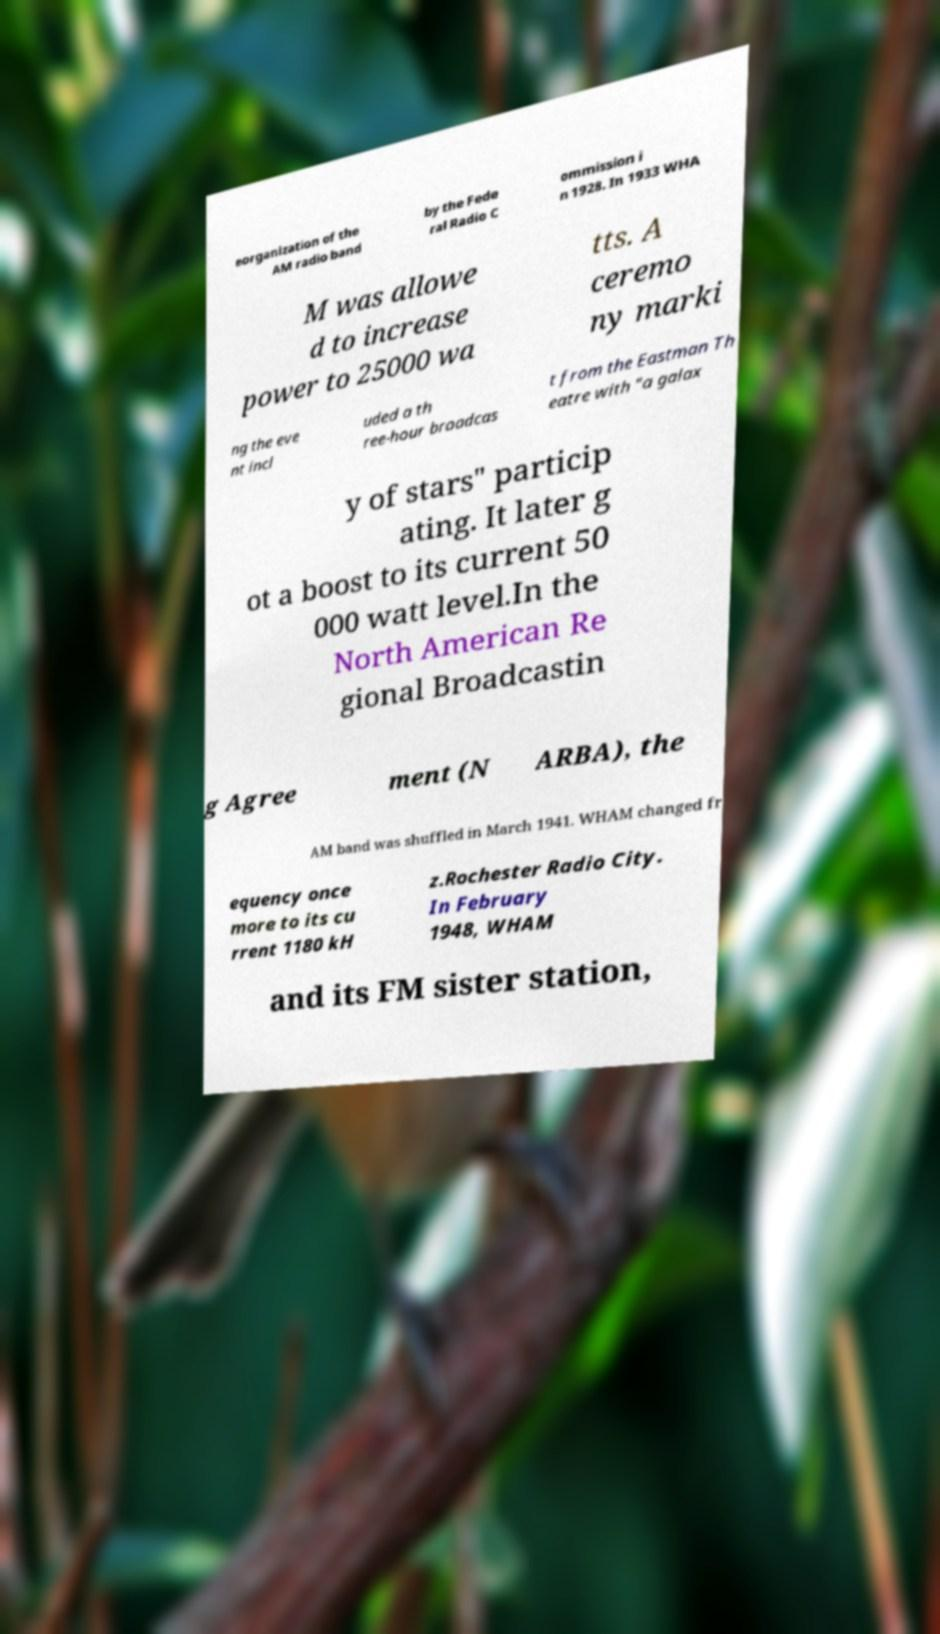There's text embedded in this image that I need extracted. Can you transcribe it verbatim? eorganization of the AM radio band by the Fede ral Radio C ommission i n 1928. In 1933 WHA M was allowe d to increase power to 25000 wa tts. A ceremo ny marki ng the eve nt incl uded a th ree-hour broadcas t from the Eastman Th eatre with "a galax y of stars" particip ating. It later g ot a boost to its current 50 000 watt level.In the North American Re gional Broadcastin g Agree ment (N ARBA), the AM band was shuffled in March 1941. WHAM changed fr equency once more to its cu rrent 1180 kH z.Rochester Radio City. In February 1948, WHAM and its FM sister station, 